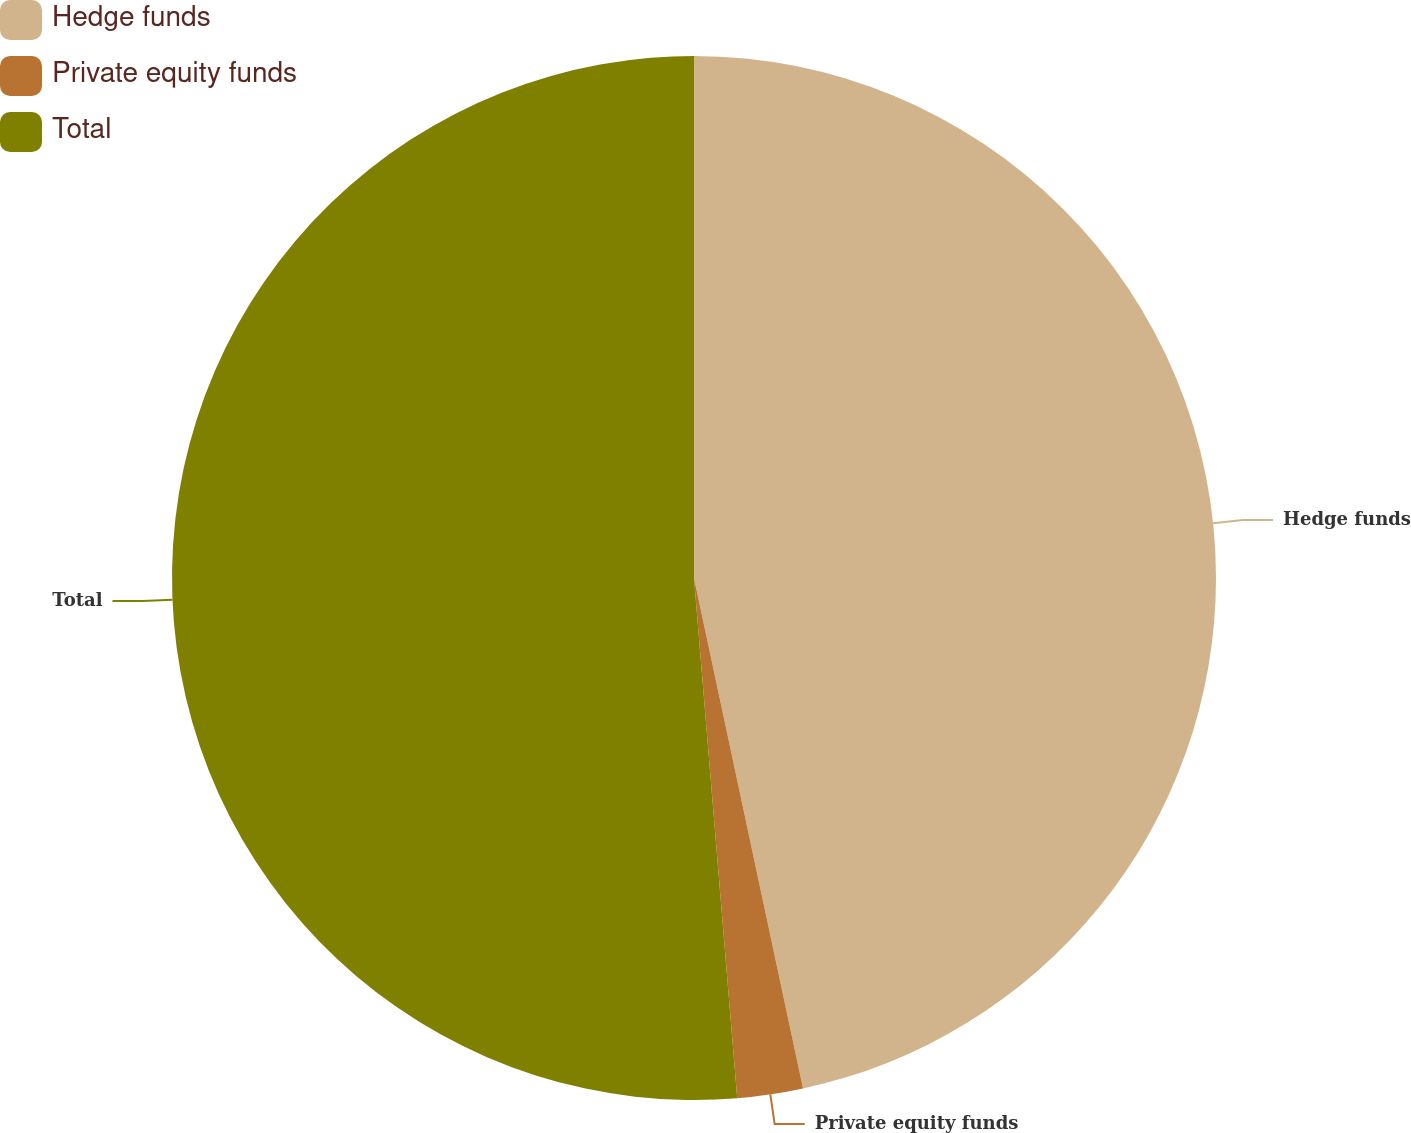<chart> <loc_0><loc_0><loc_500><loc_500><pie_chart><fcel>Hedge funds<fcel>Private equity funds<fcel>Total<nl><fcel>46.65%<fcel>2.03%<fcel>51.32%<nl></chart> 